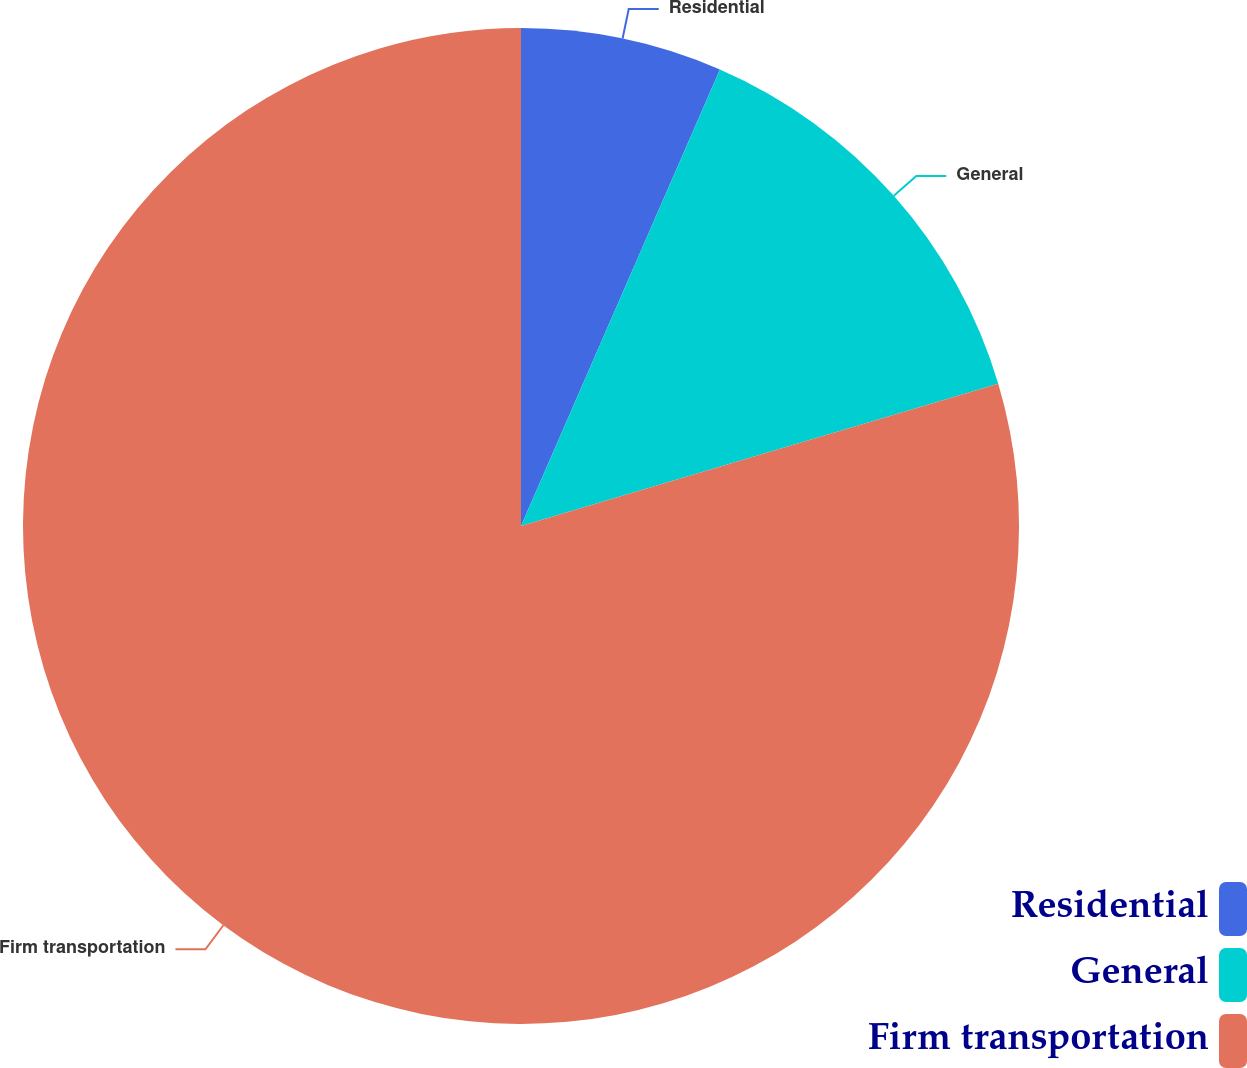Convert chart. <chart><loc_0><loc_0><loc_500><loc_500><pie_chart><fcel>Residential<fcel>General<fcel>Firm transportation<nl><fcel>6.54%<fcel>13.85%<fcel>79.61%<nl></chart> 